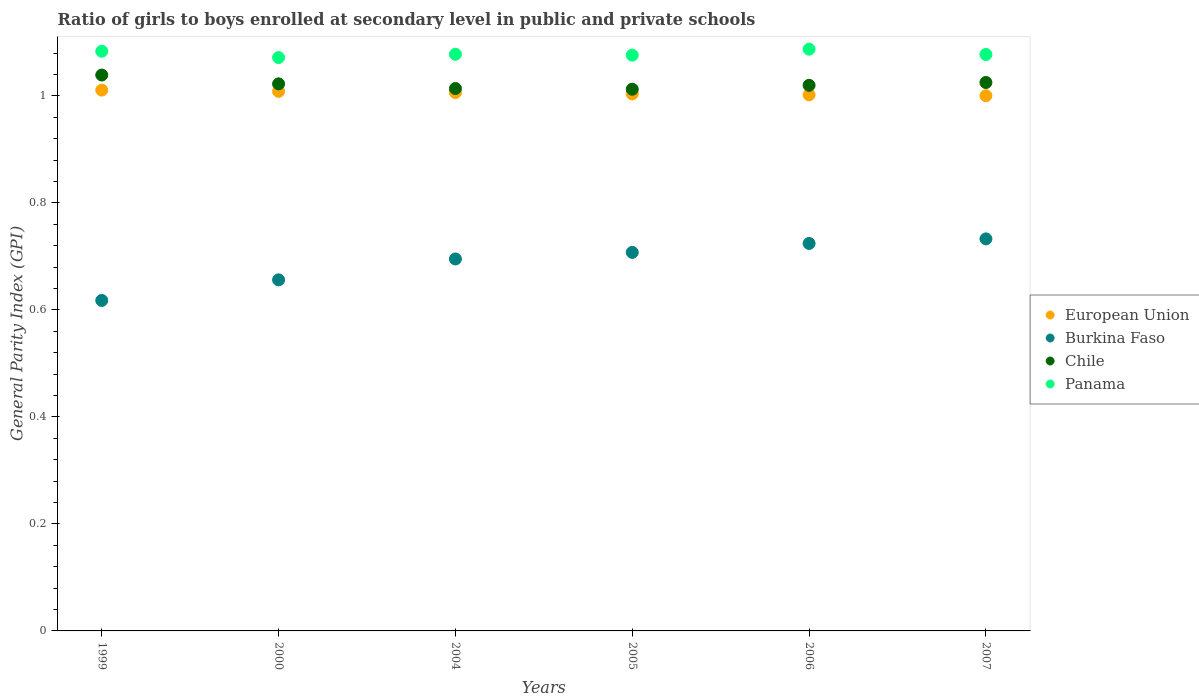How many different coloured dotlines are there?
Offer a terse response. 4. Is the number of dotlines equal to the number of legend labels?
Ensure brevity in your answer.  Yes. What is the general parity index in Panama in 2006?
Offer a very short reply. 1.09. Across all years, what is the maximum general parity index in Burkina Faso?
Your response must be concise. 0.73. Across all years, what is the minimum general parity index in European Union?
Your answer should be very brief. 1. In which year was the general parity index in Chile maximum?
Give a very brief answer. 1999. In which year was the general parity index in Burkina Faso minimum?
Provide a short and direct response. 1999. What is the total general parity index in Panama in the graph?
Provide a short and direct response. 6.47. What is the difference between the general parity index in Panama in 2005 and that in 2006?
Provide a short and direct response. -0.01. What is the difference between the general parity index in Burkina Faso in 1999 and the general parity index in European Union in 2007?
Provide a succinct answer. -0.38. What is the average general parity index in Panama per year?
Provide a succinct answer. 1.08. In the year 2004, what is the difference between the general parity index in European Union and general parity index in Panama?
Your response must be concise. -0.07. What is the ratio of the general parity index in Chile in 2000 to that in 2004?
Keep it short and to the point. 1.01. Is the general parity index in Burkina Faso in 2004 less than that in 2007?
Offer a terse response. Yes. What is the difference between the highest and the second highest general parity index in Panama?
Provide a succinct answer. 0. What is the difference between the highest and the lowest general parity index in Panama?
Keep it short and to the point. 0.02. Is the sum of the general parity index in European Union in 2004 and 2007 greater than the maximum general parity index in Panama across all years?
Your answer should be very brief. Yes. Is it the case that in every year, the sum of the general parity index in Burkina Faso and general parity index in Panama  is greater than the sum of general parity index in European Union and general parity index in Chile?
Ensure brevity in your answer.  No. Is the general parity index in Chile strictly greater than the general parity index in Panama over the years?
Provide a succinct answer. No. Is the general parity index in Chile strictly less than the general parity index in Burkina Faso over the years?
Offer a terse response. No. How many years are there in the graph?
Offer a very short reply. 6. What is the difference between two consecutive major ticks on the Y-axis?
Ensure brevity in your answer.  0.2. Does the graph contain any zero values?
Ensure brevity in your answer.  No. Does the graph contain grids?
Keep it short and to the point. No. Where does the legend appear in the graph?
Offer a very short reply. Center right. How are the legend labels stacked?
Provide a short and direct response. Vertical. What is the title of the graph?
Provide a short and direct response. Ratio of girls to boys enrolled at secondary level in public and private schools. What is the label or title of the Y-axis?
Provide a short and direct response. General Parity Index (GPI). What is the General Parity Index (GPI) in European Union in 1999?
Offer a very short reply. 1.01. What is the General Parity Index (GPI) of Burkina Faso in 1999?
Keep it short and to the point. 0.62. What is the General Parity Index (GPI) in Chile in 1999?
Provide a short and direct response. 1.04. What is the General Parity Index (GPI) in Panama in 1999?
Offer a terse response. 1.08. What is the General Parity Index (GPI) of European Union in 2000?
Your answer should be compact. 1.01. What is the General Parity Index (GPI) in Burkina Faso in 2000?
Make the answer very short. 0.66. What is the General Parity Index (GPI) in Chile in 2000?
Your answer should be compact. 1.02. What is the General Parity Index (GPI) in Panama in 2000?
Your answer should be very brief. 1.07. What is the General Parity Index (GPI) of European Union in 2004?
Offer a terse response. 1.01. What is the General Parity Index (GPI) of Burkina Faso in 2004?
Your answer should be very brief. 0.7. What is the General Parity Index (GPI) in Chile in 2004?
Keep it short and to the point. 1.01. What is the General Parity Index (GPI) in Panama in 2004?
Provide a short and direct response. 1.08. What is the General Parity Index (GPI) in European Union in 2005?
Offer a very short reply. 1. What is the General Parity Index (GPI) of Burkina Faso in 2005?
Offer a terse response. 0.71. What is the General Parity Index (GPI) in Chile in 2005?
Your response must be concise. 1.01. What is the General Parity Index (GPI) in Panama in 2005?
Your answer should be very brief. 1.08. What is the General Parity Index (GPI) of European Union in 2006?
Your answer should be compact. 1. What is the General Parity Index (GPI) of Burkina Faso in 2006?
Make the answer very short. 0.72. What is the General Parity Index (GPI) of Chile in 2006?
Offer a very short reply. 1.02. What is the General Parity Index (GPI) of Panama in 2006?
Keep it short and to the point. 1.09. What is the General Parity Index (GPI) of European Union in 2007?
Provide a short and direct response. 1. What is the General Parity Index (GPI) in Burkina Faso in 2007?
Make the answer very short. 0.73. What is the General Parity Index (GPI) in Chile in 2007?
Provide a succinct answer. 1.03. What is the General Parity Index (GPI) of Panama in 2007?
Give a very brief answer. 1.08. Across all years, what is the maximum General Parity Index (GPI) of European Union?
Provide a succinct answer. 1.01. Across all years, what is the maximum General Parity Index (GPI) in Burkina Faso?
Provide a succinct answer. 0.73. Across all years, what is the maximum General Parity Index (GPI) of Chile?
Your answer should be compact. 1.04. Across all years, what is the maximum General Parity Index (GPI) in Panama?
Provide a short and direct response. 1.09. Across all years, what is the minimum General Parity Index (GPI) of European Union?
Ensure brevity in your answer.  1. Across all years, what is the minimum General Parity Index (GPI) in Burkina Faso?
Keep it short and to the point. 0.62. Across all years, what is the minimum General Parity Index (GPI) of Chile?
Make the answer very short. 1.01. Across all years, what is the minimum General Parity Index (GPI) of Panama?
Ensure brevity in your answer.  1.07. What is the total General Parity Index (GPI) in European Union in the graph?
Your response must be concise. 6.03. What is the total General Parity Index (GPI) in Burkina Faso in the graph?
Provide a succinct answer. 4.13. What is the total General Parity Index (GPI) in Chile in the graph?
Provide a short and direct response. 6.13. What is the total General Parity Index (GPI) of Panama in the graph?
Give a very brief answer. 6.47. What is the difference between the General Parity Index (GPI) in European Union in 1999 and that in 2000?
Give a very brief answer. 0. What is the difference between the General Parity Index (GPI) of Burkina Faso in 1999 and that in 2000?
Your answer should be compact. -0.04. What is the difference between the General Parity Index (GPI) of Chile in 1999 and that in 2000?
Your answer should be very brief. 0.02. What is the difference between the General Parity Index (GPI) in Panama in 1999 and that in 2000?
Provide a succinct answer. 0.01. What is the difference between the General Parity Index (GPI) in European Union in 1999 and that in 2004?
Provide a succinct answer. 0. What is the difference between the General Parity Index (GPI) in Burkina Faso in 1999 and that in 2004?
Give a very brief answer. -0.08. What is the difference between the General Parity Index (GPI) of Chile in 1999 and that in 2004?
Ensure brevity in your answer.  0.03. What is the difference between the General Parity Index (GPI) in Panama in 1999 and that in 2004?
Make the answer very short. 0.01. What is the difference between the General Parity Index (GPI) of European Union in 1999 and that in 2005?
Your answer should be very brief. 0.01. What is the difference between the General Parity Index (GPI) in Burkina Faso in 1999 and that in 2005?
Keep it short and to the point. -0.09. What is the difference between the General Parity Index (GPI) of Chile in 1999 and that in 2005?
Offer a terse response. 0.03. What is the difference between the General Parity Index (GPI) in Panama in 1999 and that in 2005?
Offer a very short reply. 0.01. What is the difference between the General Parity Index (GPI) of European Union in 1999 and that in 2006?
Ensure brevity in your answer.  0.01. What is the difference between the General Parity Index (GPI) in Burkina Faso in 1999 and that in 2006?
Keep it short and to the point. -0.11. What is the difference between the General Parity Index (GPI) of Chile in 1999 and that in 2006?
Keep it short and to the point. 0.02. What is the difference between the General Parity Index (GPI) of Panama in 1999 and that in 2006?
Provide a succinct answer. -0. What is the difference between the General Parity Index (GPI) of European Union in 1999 and that in 2007?
Your answer should be compact. 0.01. What is the difference between the General Parity Index (GPI) in Burkina Faso in 1999 and that in 2007?
Ensure brevity in your answer.  -0.12. What is the difference between the General Parity Index (GPI) in Chile in 1999 and that in 2007?
Ensure brevity in your answer.  0.01. What is the difference between the General Parity Index (GPI) of Panama in 1999 and that in 2007?
Keep it short and to the point. 0.01. What is the difference between the General Parity Index (GPI) of European Union in 2000 and that in 2004?
Make the answer very short. 0. What is the difference between the General Parity Index (GPI) of Burkina Faso in 2000 and that in 2004?
Offer a terse response. -0.04. What is the difference between the General Parity Index (GPI) in Chile in 2000 and that in 2004?
Offer a terse response. 0.01. What is the difference between the General Parity Index (GPI) of Panama in 2000 and that in 2004?
Your answer should be compact. -0.01. What is the difference between the General Parity Index (GPI) of European Union in 2000 and that in 2005?
Your answer should be compact. 0. What is the difference between the General Parity Index (GPI) of Burkina Faso in 2000 and that in 2005?
Provide a succinct answer. -0.05. What is the difference between the General Parity Index (GPI) of Panama in 2000 and that in 2005?
Provide a succinct answer. -0. What is the difference between the General Parity Index (GPI) of European Union in 2000 and that in 2006?
Your response must be concise. 0.01. What is the difference between the General Parity Index (GPI) of Burkina Faso in 2000 and that in 2006?
Keep it short and to the point. -0.07. What is the difference between the General Parity Index (GPI) in Chile in 2000 and that in 2006?
Give a very brief answer. 0. What is the difference between the General Parity Index (GPI) in Panama in 2000 and that in 2006?
Your answer should be compact. -0.02. What is the difference between the General Parity Index (GPI) of European Union in 2000 and that in 2007?
Offer a terse response. 0.01. What is the difference between the General Parity Index (GPI) of Burkina Faso in 2000 and that in 2007?
Your answer should be compact. -0.08. What is the difference between the General Parity Index (GPI) of Chile in 2000 and that in 2007?
Keep it short and to the point. -0. What is the difference between the General Parity Index (GPI) of Panama in 2000 and that in 2007?
Your answer should be compact. -0.01. What is the difference between the General Parity Index (GPI) of European Union in 2004 and that in 2005?
Your answer should be compact. 0. What is the difference between the General Parity Index (GPI) in Burkina Faso in 2004 and that in 2005?
Offer a terse response. -0.01. What is the difference between the General Parity Index (GPI) of Chile in 2004 and that in 2005?
Your answer should be compact. 0. What is the difference between the General Parity Index (GPI) in Panama in 2004 and that in 2005?
Make the answer very short. 0. What is the difference between the General Parity Index (GPI) in European Union in 2004 and that in 2006?
Offer a very short reply. 0. What is the difference between the General Parity Index (GPI) of Burkina Faso in 2004 and that in 2006?
Make the answer very short. -0.03. What is the difference between the General Parity Index (GPI) of Chile in 2004 and that in 2006?
Give a very brief answer. -0.01. What is the difference between the General Parity Index (GPI) of Panama in 2004 and that in 2006?
Provide a short and direct response. -0.01. What is the difference between the General Parity Index (GPI) of European Union in 2004 and that in 2007?
Your response must be concise. 0.01. What is the difference between the General Parity Index (GPI) in Burkina Faso in 2004 and that in 2007?
Your answer should be compact. -0.04. What is the difference between the General Parity Index (GPI) of Chile in 2004 and that in 2007?
Your answer should be very brief. -0.01. What is the difference between the General Parity Index (GPI) in Panama in 2004 and that in 2007?
Your response must be concise. 0. What is the difference between the General Parity Index (GPI) of European Union in 2005 and that in 2006?
Offer a very short reply. 0. What is the difference between the General Parity Index (GPI) in Burkina Faso in 2005 and that in 2006?
Provide a short and direct response. -0.02. What is the difference between the General Parity Index (GPI) of Chile in 2005 and that in 2006?
Make the answer very short. -0.01. What is the difference between the General Parity Index (GPI) in Panama in 2005 and that in 2006?
Provide a short and direct response. -0.01. What is the difference between the General Parity Index (GPI) in European Union in 2005 and that in 2007?
Provide a succinct answer. 0. What is the difference between the General Parity Index (GPI) in Burkina Faso in 2005 and that in 2007?
Offer a terse response. -0.03. What is the difference between the General Parity Index (GPI) in Chile in 2005 and that in 2007?
Keep it short and to the point. -0.01. What is the difference between the General Parity Index (GPI) of Panama in 2005 and that in 2007?
Provide a succinct answer. -0. What is the difference between the General Parity Index (GPI) of European Union in 2006 and that in 2007?
Make the answer very short. 0. What is the difference between the General Parity Index (GPI) in Burkina Faso in 2006 and that in 2007?
Your answer should be very brief. -0.01. What is the difference between the General Parity Index (GPI) of Chile in 2006 and that in 2007?
Keep it short and to the point. -0.01. What is the difference between the General Parity Index (GPI) of Panama in 2006 and that in 2007?
Provide a short and direct response. 0.01. What is the difference between the General Parity Index (GPI) of European Union in 1999 and the General Parity Index (GPI) of Burkina Faso in 2000?
Keep it short and to the point. 0.35. What is the difference between the General Parity Index (GPI) in European Union in 1999 and the General Parity Index (GPI) in Chile in 2000?
Provide a succinct answer. -0.01. What is the difference between the General Parity Index (GPI) in European Union in 1999 and the General Parity Index (GPI) in Panama in 2000?
Your answer should be compact. -0.06. What is the difference between the General Parity Index (GPI) of Burkina Faso in 1999 and the General Parity Index (GPI) of Chile in 2000?
Keep it short and to the point. -0.4. What is the difference between the General Parity Index (GPI) in Burkina Faso in 1999 and the General Parity Index (GPI) in Panama in 2000?
Offer a terse response. -0.45. What is the difference between the General Parity Index (GPI) in Chile in 1999 and the General Parity Index (GPI) in Panama in 2000?
Your answer should be very brief. -0.03. What is the difference between the General Parity Index (GPI) in European Union in 1999 and the General Parity Index (GPI) in Burkina Faso in 2004?
Your answer should be very brief. 0.32. What is the difference between the General Parity Index (GPI) of European Union in 1999 and the General Parity Index (GPI) of Chile in 2004?
Offer a very short reply. -0. What is the difference between the General Parity Index (GPI) in European Union in 1999 and the General Parity Index (GPI) in Panama in 2004?
Provide a succinct answer. -0.07. What is the difference between the General Parity Index (GPI) in Burkina Faso in 1999 and the General Parity Index (GPI) in Chile in 2004?
Your response must be concise. -0.4. What is the difference between the General Parity Index (GPI) of Burkina Faso in 1999 and the General Parity Index (GPI) of Panama in 2004?
Provide a short and direct response. -0.46. What is the difference between the General Parity Index (GPI) of Chile in 1999 and the General Parity Index (GPI) of Panama in 2004?
Your answer should be compact. -0.04. What is the difference between the General Parity Index (GPI) of European Union in 1999 and the General Parity Index (GPI) of Burkina Faso in 2005?
Offer a terse response. 0.3. What is the difference between the General Parity Index (GPI) in European Union in 1999 and the General Parity Index (GPI) in Chile in 2005?
Your response must be concise. -0. What is the difference between the General Parity Index (GPI) of European Union in 1999 and the General Parity Index (GPI) of Panama in 2005?
Your answer should be very brief. -0.07. What is the difference between the General Parity Index (GPI) in Burkina Faso in 1999 and the General Parity Index (GPI) in Chile in 2005?
Provide a short and direct response. -0.39. What is the difference between the General Parity Index (GPI) of Burkina Faso in 1999 and the General Parity Index (GPI) of Panama in 2005?
Provide a succinct answer. -0.46. What is the difference between the General Parity Index (GPI) in Chile in 1999 and the General Parity Index (GPI) in Panama in 2005?
Make the answer very short. -0.04. What is the difference between the General Parity Index (GPI) of European Union in 1999 and the General Parity Index (GPI) of Burkina Faso in 2006?
Offer a very short reply. 0.29. What is the difference between the General Parity Index (GPI) of European Union in 1999 and the General Parity Index (GPI) of Chile in 2006?
Ensure brevity in your answer.  -0.01. What is the difference between the General Parity Index (GPI) in European Union in 1999 and the General Parity Index (GPI) in Panama in 2006?
Offer a very short reply. -0.08. What is the difference between the General Parity Index (GPI) in Burkina Faso in 1999 and the General Parity Index (GPI) in Chile in 2006?
Provide a succinct answer. -0.4. What is the difference between the General Parity Index (GPI) of Burkina Faso in 1999 and the General Parity Index (GPI) of Panama in 2006?
Provide a short and direct response. -0.47. What is the difference between the General Parity Index (GPI) in Chile in 1999 and the General Parity Index (GPI) in Panama in 2006?
Ensure brevity in your answer.  -0.05. What is the difference between the General Parity Index (GPI) in European Union in 1999 and the General Parity Index (GPI) in Burkina Faso in 2007?
Make the answer very short. 0.28. What is the difference between the General Parity Index (GPI) in European Union in 1999 and the General Parity Index (GPI) in Chile in 2007?
Provide a succinct answer. -0.01. What is the difference between the General Parity Index (GPI) in European Union in 1999 and the General Parity Index (GPI) in Panama in 2007?
Your answer should be very brief. -0.07. What is the difference between the General Parity Index (GPI) in Burkina Faso in 1999 and the General Parity Index (GPI) in Chile in 2007?
Provide a short and direct response. -0.41. What is the difference between the General Parity Index (GPI) in Burkina Faso in 1999 and the General Parity Index (GPI) in Panama in 2007?
Ensure brevity in your answer.  -0.46. What is the difference between the General Parity Index (GPI) of Chile in 1999 and the General Parity Index (GPI) of Panama in 2007?
Your response must be concise. -0.04. What is the difference between the General Parity Index (GPI) of European Union in 2000 and the General Parity Index (GPI) of Burkina Faso in 2004?
Your answer should be very brief. 0.31. What is the difference between the General Parity Index (GPI) in European Union in 2000 and the General Parity Index (GPI) in Chile in 2004?
Provide a short and direct response. -0.01. What is the difference between the General Parity Index (GPI) of European Union in 2000 and the General Parity Index (GPI) of Panama in 2004?
Keep it short and to the point. -0.07. What is the difference between the General Parity Index (GPI) of Burkina Faso in 2000 and the General Parity Index (GPI) of Chile in 2004?
Your answer should be compact. -0.36. What is the difference between the General Parity Index (GPI) in Burkina Faso in 2000 and the General Parity Index (GPI) in Panama in 2004?
Your answer should be very brief. -0.42. What is the difference between the General Parity Index (GPI) of Chile in 2000 and the General Parity Index (GPI) of Panama in 2004?
Make the answer very short. -0.06. What is the difference between the General Parity Index (GPI) in European Union in 2000 and the General Parity Index (GPI) in Burkina Faso in 2005?
Give a very brief answer. 0.3. What is the difference between the General Parity Index (GPI) in European Union in 2000 and the General Parity Index (GPI) in Chile in 2005?
Give a very brief answer. -0. What is the difference between the General Parity Index (GPI) in European Union in 2000 and the General Parity Index (GPI) in Panama in 2005?
Offer a very short reply. -0.07. What is the difference between the General Parity Index (GPI) in Burkina Faso in 2000 and the General Parity Index (GPI) in Chile in 2005?
Your answer should be very brief. -0.36. What is the difference between the General Parity Index (GPI) in Burkina Faso in 2000 and the General Parity Index (GPI) in Panama in 2005?
Provide a short and direct response. -0.42. What is the difference between the General Parity Index (GPI) of Chile in 2000 and the General Parity Index (GPI) of Panama in 2005?
Give a very brief answer. -0.05. What is the difference between the General Parity Index (GPI) of European Union in 2000 and the General Parity Index (GPI) of Burkina Faso in 2006?
Offer a very short reply. 0.28. What is the difference between the General Parity Index (GPI) in European Union in 2000 and the General Parity Index (GPI) in Chile in 2006?
Offer a very short reply. -0.01. What is the difference between the General Parity Index (GPI) of European Union in 2000 and the General Parity Index (GPI) of Panama in 2006?
Offer a very short reply. -0.08. What is the difference between the General Parity Index (GPI) of Burkina Faso in 2000 and the General Parity Index (GPI) of Chile in 2006?
Your answer should be very brief. -0.36. What is the difference between the General Parity Index (GPI) in Burkina Faso in 2000 and the General Parity Index (GPI) in Panama in 2006?
Your response must be concise. -0.43. What is the difference between the General Parity Index (GPI) of Chile in 2000 and the General Parity Index (GPI) of Panama in 2006?
Ensure brevity in your answer.  -0.06. What is the difference between the General Parity Index (GPI) in European Union in 2000 and the General Parity Index (GPI) in Burkina Faso in 2007?
Offer a terse response. 0.28. What is the difference between the General Parity Index (GPI) of European Union in 2000 and the General Parity Index (GPI) of Chile in 2007?
Give a very brief answer. -0.02. What is the difference between the General Parity Index (GPI) in European Union in 2000 and the General Parity Index (GPI) in Panama in 2007?
Offer a terse response. -0.07. What is the difference between the General Parity Index (GPI) in Burkina Faso in 2000 and the General Parity Index (GPI) in Chile in 2007?
Make the answer very short. -0.37. What is the difference between the General Parity Index (GPI) of Burkina Faso in 2000 and the General Parity Index (GPI) of Panama in 2007?
Ensure brevity in your answer.  -0.42. What is the difference between the General Parity Index (GPI) in Chile in 2000 and the General Parity Index (GPI) in Panama in 2007?
Your answer should be very brief. -0.05. What is the difference between the General Parity Index (GPI) in European Union in 2004 and the General Parity Index (GPI) in Burkina Faso in 2005?
Give a very brief answer. 0.3. What is the difference between the General Parity Index (GPI) of European Union in 2004 and the General Parity Index (GPI) of Chile in 2005?
Offer a very short reply. -0.01. What is the difference between the General Parity Index (GPI) of European Union in 2004 and the General Parity Index (GPI) of Panama in 2005?
Provide a succinct answer. -0.07. What is the difference between the General Parity Index (GPI) of Burkina Faso in 2004 and the General Parity Index (GPI) of Chile in 2005?
Give a very brief answer. -0.32. What is the difference between the General Parity Index (GPI) in Burkina Faso in 2004 and the General Parity Index (GPI) in Panama in 2005?
Offer a very short reply. -0.38. What is the difference between the General Parity Index (GPI) of Chile in 2004 and the General Parity Index (GPI) of Panama in 2005?
Make the answer very short. -0.06. What is the difference between the General Parity Index (GPI) in European Union in 2004 and the General Parity Index (GPI) in Burkina Faso in 2006?
Keep it short and to the point. 0.28. What is the difference between the General Parity Index (GPI) in European Union in 2004 and the General Parity Index (GPI) in Chile in 2006?
Ensure brevity in your answer.  -0.01. What is the difference between the General Parity Index (GPI) in European Union in 2004 and the General Parity Index (GPI) in Panama in 2006?
Give a very brief answer. -0.08. What is the difference between the General Parity Index (GPI) in Burkina Faso in 2004 and the General Parity Index (GPI) in Chile in 2006?
Give a very brief answer. -0.32. What is the difference between the General Parity Index (GPI) of Burkina Faso in 2004 and the General Parity Index (GPI) of Panama in 2006?
Offer a very short reply. -0.39. What is the difference between the General Parity Index (GPI) in Chile in 2004 and the General Parity Index (GPI) in Panama in 2006?
Provide a succinct answer. -0.07. What is the difference between the General Parity Index (GPI) of European Union in 2004 and the General Parity Index (GPI) of Burkina Faso in 2007?
Your answer should be compact. 0.27. What is the difference between the General Parity Index (GPI) in European Union in 2004 and the General Parity Index (GPI) in Chile in 2007?
Make the answer very short. -0.02. What is the difference between the General Parity Index (GPI) of European Union in 2004 and the General Parity Index (GPI) of Panama in 2007?
Your answer should be very brief. -0.07. What is the difference between the General Parity Index (GPI) of Burkina Faso in 2004 and the General Parity Index (GPI) of Chile in 2007?
Provide a short and direct response. -0.33. What is the difference between the General Parity Index (GPI) in Burkina Faso in 2004 and the General Parity Index (GPI) in Panama in 2007?
Your answer should be compact. -0.38. What is the difference between the General Parity Index (GPI) of Chile in 2004 and the General Parity Index (GPI) of Panama in 2007?
Offer a terse response. -0.06. What is the difference between the General Parity Index (GPI) of European Union in 2005 and the General Parity Index (GPI) of Burkina Faso in 2006?
Ensure brevity in your answer.  0.28. What is the difference between the General Parity Index (GPI) of European Union in 2005 and the General Parity Index (GPI) of Chile in 2006?
Your response must be concise. -0.02. What is the difference between the General Parity Index (GPI) in European Union in 2005 and the General Parity Index (GPI) in Panama in 2006?
Offer a very short reply. -0.08. What is the difference between the General Parity Index (GPI) of Burkina Faso in 2005 and the General Parity Index (GPI) of Chile in 2006?
Your response must be concise. -0.31. What is the difference between the General Parity Index (GPI) of Burkina Faso in 2005 and the General Parity Index (GPI) of Panama in 2006?
Give a very brief answer. -0.38. What is the difference between the General Parity Index (GPI) in Chile in 2005 and the General Parity Index (GPI) in Panama in 2006?
Provide a short and direct response. -0.07. What is the difference between the General Parity Index (GPI) of European Union in 2005 and the General Parity Index (GPI) of Burkina Faso in 2007?
Keep it short and to the point. 0.27. What is the difference between the General Parity Index (GPI) in European Union in 2005 and the General Parity Index (GPI) in Chile in 2007?
Offer a very short reply. -0.02. What is the difference between the General Parity Index (GPI) of European Union in 2005 and the General Parity Index (GPI) of Panama in 2007?
Ensure brevity in your answer.  -0.07. What is the difference between the General Parity Index (GPI) in Burkina Faso in 2005 and the General Parity Index (GPI) in Chile in 2007?
Offer a very short reply. -0.32. What is the difference between the General Parity Index (GPI) in Burkina Faso in 2005 and the General Parity Index (GPI) in Panama in 2007?
Provide a short and direct response. -0.37. What is the difference between the General Parity Index (GPI) of Chile in 2005 and the General Parity Index (GPI) of Panama in 2007?
Provide a short and direct response. -0.06. What is the difference between the General Parity Index (GPI) in European Union in 2006 and the General Parity Index (GPI) in Burkina Faso in 2007?
Your answer should be compact. 0.27. What is the difference between the General Parity Index (GPI) of European Union in 2006 and the General Parity Index (GPI) of Chile in 2007?
Give a very brief answer. -0.02. What is the difference between the General Parity Index (GPI) of European Union in 2006 and the General Parity Index (GPI) of Panama in 2007?
Offer a very short reply. -0.08. What is the difference between the General Parity Index (GPI) in Burkina Faso in 2006 and the General Parity Index (GPI) in Chile in 2007?
Your response must be concise. -0.3. What is the difference between the General Parity Index (GPI) of Burkina Faso in 2006 and the General Parity Index (GPI) of Panama in 2007?
Make the answer very short. -0.35. What is the difference between the General Parity Index (GPI) of Chile in 2006 and the General Parity Index (GPI) of Panama in 2007?
Your response must be concise. -0.06. What is the average General Parity Index (GPI) of European Union per year?
Your response must be concise. 1.01. What is the average General Parity Index (GPI) in Burkina Faso per year?
Your response must be concise. 0.69. What is the average General Parity Index (GPI) of Chile per year?
Provide a short and direct response. 1.02. What is the average General Parity Index (GPI) in Panama per year?
Your answer should be compact. 1.08. In the year 1999, what is the difference between the General Parity Index (GPI) in European Union and General Parity Index (GPI) in Burkina Faso?
Your answer should be very brief. 0.39. In the year 1999, what is the difference between the General Parity Index (GPI) of European Union and General Parity Index (GPI) of Chile?
Offer a very short reply. -0.03. In the year 1999, what is the difference between the General Parity Index (GPI) of European Union and General Parity Index (GPI) of Panama?
Your answer should be very brief. -0.07. In the year 1999, what is the difference between the General Parity Index (GPI) of Burkina Faso and General Parity Index (GPI) of Chile?
Provide a succinct answer. -0.42. In the year 1999, what is the difference between the General Parity Index (GPI) of Burkina Faso and General Parity Index (GPI) of Panama?
Provide a succinct answer. -0.47. In the year 1999, what is the difference between the General Parity Index (GPI) in Chile and General Parity Index (GPI) in Panama?
Provide a succinct answer. -0.04. In the year 2000, what is the difference between the General Parity Index (GPI) in European Union and General Parity Index (GPI) in Burkina Faso?
Provide a succinct answer. 0.35. In the year 2000, what is the difference between the General Parity Index (GPI) in European Union and General Parity Index (GPI) in Chile?
Keep it short and to the point. -0.01. In the year 2000, what is the difference between the General Parity Index (GPI) of European Union and General Parity Index (GPI) of Panama?
Offer a terse response. -0.06. In the year 2000, what is the difference between the General Parity Index (GPI) of Burkina Faso and General Parity Index (GPI) of Chile?
Make the answer very short. -0.37. In the year 2000, what is the difference between the General Parity Index (GPI) of Burkina Faso and General Parity Index (GPI) of Panama?
Provide a short and direct response. -0.42. In the year 2000, what is the difference between the General Parity Index (GPI) of Chile and General Parity Index (GPI) of Panama?
Your answer should be very brief. -0.05. In the year 2004, what is the difference between the General Parity Index (GPI) in European Union and General Parity Index (GPI) in Burkina Faso?
Give a very brief answer. 0.31. In the year 2004, what is the difference between the General Parity Index (GPI) of European Union and General Parity Index (GPI) of Chile?
Give a very brief answer. -0.01. In the year 2004, what is the difference between the General Parity Index (GPI) in European Union and General Parity Index (GPI) in Panama?
Ensure brevity in your answer.  -0.07. In the year 2004, what is the difference between the General Parity Index (GPI) of Burkina Faso and General Parity Index (GPI) of Chile?
Offer a terse response. -0.32. In the year 2004, what is the difference between the General Parity Index (GPI) of Burkina Faso and General Parity Index (GPI) of Panama?
Offer a very short reply. -0.38. In the year 2004, what is the difference between the General Parity Index (GPI) of Chile and General Parity Index (GPI) of Panama?
Provide a short and direct response. -0.06. In the year 2005, what is the difference between the General Parity Index (GPI) in European Union and General Parity Index (GPI) in Burkina Faso?
Your answer should be compact. 0.3. In the year 2005, what is the difference between the General Parity Index (GPI) in European Union and General Parity Index (GPI) in Chile?
Provide a succinct answer. -0.01. In the year 2005, what is the difference between the General Parity Index (GPI) of European Union and General Parity Index (GPI) of Panama?
Give a very brief answer. -0.07. In the year 2005, what is the difference between the General Parity Index (GPI) of Burkina Faso and General Parity Index (GPI) of Chile?
Your answer should be compact. -0.3. In the year 2005, what is the difference between the General Parity Index (GPI) of Burkina Faso and General Parity Index (GPI) of Panama?
Your answer should be very brief. -0.37. In the year 2005, what is the difference between the General Parity Index (GPI) of Chile and General Parity Index (GPI) of Panama?
Offer a very short reply. -0.06. In the year 2006, what is the difference between the General Parity Index (GPI) of European Union and General Parity Index (GPI) of Burkina Faso?
Provide a succinct answer. 0.28. In the year 2006, what is the difference between the General Parity Index (GPI) of European Union and General Parity Index (GPI) of Chile?
Offer a terse response. -0.02. In the year 2006, what is the difference between the General Parity Index (GPI) in European Union and General Parity Index (GPI) in Panama?
Offer a very short reply. -0.09. In the year 2006, what is the difference between the General Parity Index (GPI) in Burkina Faso and General Parity Index (GPI) in Chile?
Your answer should be compact. -0.3. In the year 2006, what is the difference between the General Parity Index (GPI) in Burkina Faso and General Parity Index (GPI) in Panama?
Keep it short and to the point. -0.36. In the year 2006, what is the difference between the General Parity Index (GPI) in Chile and General Parity Index (GPI) in Panama?
Give a very brief answer. -0.07. In the year 2007, what is the difference between the General Parity Index (GPI) in European Union and General Parity Index (GPI) in Burkina Faso?
Keep it short and to the point. 0.27. In the year 2007, what is the difference between the General Parity Index (GPI) of European Union and General Parity Index (GPI) of Chile?
Your answer should be very brief. -0.02. In the year 2007, what is the difference between the General Parity Index (GPI) of European Union and General Parity Index (GPI) of Panama?
Provide a short and direct response. -0.08. In the year 2007, what is the difference between the General Parity Index (GPI) of Burkina Faso and General Parity Index (GPI) of Chile?
Offer a terse response. -0.29. In the year 2007, what is the difference between the General Parity Index (GPI) in Burkina Faso and General Parity Index (GPI) in Panama?
Your answer should be compact. -0.34. In the year 2007, what is the difference between the General Parity Index (GPI) in Chile and General Parity Index (GPI) in Panama?
Your answer should be compact. -0.05. What is the ratio of the General Parity Index (GPI) of European Union in 1999 to that in 2000?
Ensure brevity in your answer.  1. What is the ratio of the General Parity Index (GPI) of Burkina Faso in 1999 to that in 2000?
Keep it short and to the point. 0.94. What is the ratio of the General Parity Index (GPI) of Chile in 1999 to that in 2000?
Make the answer very short. 1.02. What is the ratio of the General Parity Index (GPI) in Panama in 1999 to that in 2000?
Offer a terse response. 1.01. What is the ratio of the General Parity Index (GPI) of European Union in 1999 to that in 2004?
Your answer should be very brief. 1. What is the ratio of the General Parity Index (GPI) of Burkina Faso in 1999 to that in 2004?
Ensure brevity in your answer.  0.89. What is the ratio of the General Parity Index (GPI) of Chile in 1999 to that in 2004?
Ensure brevity in your answer.  1.02. What is the ratio of the General Parity Index (GPI) of European Union in 1999 to that in 2005?
Offer a terse response. 1.01. What is the ratio of the General Parity Index (GPI) in Burkina Faso in 1999 to that in 2005?
Ensure brevity in your answer.  0.87. What is the ratio of the General Parity Index (GPI) in Chile in 1999 to that in 2005?
Ensure brevity in your answer.  1.03. What is the ratio of the General Parity Index (GPI) of Panama in 1999 to that in 2005?
Your answer should be very brief. 1.01. What is the ratio of the General Parity Index (GPI) in European Union in 1999 to that in 2006?
Your answer should be compact. 1.01. What is the ratio of the General Parity Index (GPI) of Burkina Faso in 1999 to that in 2006?
Ensure brevity in your answer.  0.85. What is the ratio of the General Parity Index (GPI) in Chile in 1999 to that in 2006?
Provide a short and direct response. 1.02. What is the ratio of the General Parity Index (GPI) of Panama in 1999 to that in 2006?
Give a very brief answer. 1. What is the ratio of the General Parity Index (GPI) of European Union in 1999 to that in 2007?
Give a very brief answer. 1.01. What is the ratio of the General Parity Index (GPI) in Burkina Faso in 1999 to that in 2007?
Offer a very short reply. 0.84. What is the ratio of the General Parity Index (GPI) in Chile in 1999 to that in 2007?
Your response must be concise. 1.01. What is the ratio of the General Parity Index (GPI) of Panama in 1999 to that in 2007?
Offer a very short reply. 1.01. What is the ratio of the General Parity Index (GPI) of Burkina Faso in 2000 to that in 2004?
Offer a terse response. 0.94. What is the ratio of the General Parity Index (GPI) of Chile in 2000 to that in 2004?
Your answer should be compact. 1.01. What is the ratio of the General Parity Index (GPI) of Burkina Faso in 2000 to that in 2005?
Your answer should be compact. 0.93. What is the ratio of the General Parity Index (GPI) in Chile in 2000 to that in 2005?
Ensure brevity in your answer.  1.01. What is the ratio of the General Parity Index (GPI) of Panama in 2000 to that in 2005?
Offer a very short reply. 1. What is the ratio of the General Parity Index (GPI) in Burkina Faso in 2000 to that in 2006?
Keep it short and to the point. 0.91. What is the ratio of the General Parity Index (GPI) in Panama in 2000 to that in 2006?
Keep it short and to the point. 0.99. What is the ratio of the General Parity Index (GPI) of European Union in 2000 to that in 2007?
Offer a terse response. 1.01. What is the ratio of the General Parity Index (GPI) in Burkina Faso in 2000 to that in 2007?
Offer a very short reply. 0.9. What is the ratio of the General Parity Index (GPI) in Chile in 2000 to that in 2007?
Your response must be concise. 1. What is the ratio of the General Parity Index (GPI) in Panama in 2000 to that in 2007?
Make the answer very short. 0.99. What is the ratio of the General Parity Index (GPI) of Burkina Faso in 2004 to that in 2005?
Your answer should be compact. 0.98. What is the ratio of the General Parity Index (GPI) in European Union in 2004 to that in 2006?
Provide a short and direct response. 1. What is the ratio of the General Parity Index (GPI) of Burkina Faso in 2004 to that in 2006?
Give a very brief answer. 0.96. What is the ratio of the General Parity Index (GPI) of European Union in 2004 to that in 2007?
Offer a terse response. 1.01. What is the ratio of the General Parity Index (GPI) in Burkina Faso in 2004 to that in 2007?
Provide a short and direct response. 0.95. What is the ratio of the General Parity Index (GPI) of European Union in 2005 to that in 2006?
Your answer should be very brief. 1. What is the ratio of the General Parity Index (GPI) in Chile in 2005 to that in 2006?
Offer a very short reply. 0.99. What is the ratio of the General Parity Index (GPI) of Burkina Faso in 2005 to that in 2007?
Ensure brevity in your answer.  0.97. What is the ratio of the General Parity Index (GPI) of Chile in 2005 to that in 2007?
Your answer should be compact. 0.99. What is the ratio of the General Parity Index (GPI) of Panama in 2005 to that in 2007?
Your answer should be compact. 1. What is the ratio of the General Parity Index (GPI) of European Union in 2006 to that in 2007?
Offer a terse response. 1. What is the ratio of the General Parity Index (GPI) of Burkina Faso in 2006 to that in 2007?
Keep it short and to the point. 0.99. What is the ratio of the General Parity Index (GPI) in Panama in 2006 to that in 2007?
Provide a short and direct response. 1.01. What is the difference between the highest and the second highest General Parity Index (GPI) in European Union?
Your answer should be very brief. 0. What is the difference between the highest and the second highest General Parity Index (GPI) of Burkina Faso?
Your response must be concise. 0.01. What is the difference between the highest and the second highest General Parity Index (GPI) of Chile?
Make the answer very short. 0.01. What is the difference between the highest and the second highest General Parity Index (GPI) of Panama?
Provide a succinct answer. 0. What is the difference between the highest and the lowest General Parity Index (GPI) in European Union?
Offer a very short reply. 0.01. What is the difference between the highest and the lowest General Parity Index (GPI) of Burkina Faso?
Ensure brevity in your answer.  0.12. What is the difference between the highest and the lowest General Parity Index (GPI) in Chile?
Your answer should be compact. 0.03. What is the difference between the highest and the lowest General Parity Index (GPI) in Panama?
Offer a terse response. 0.02. 